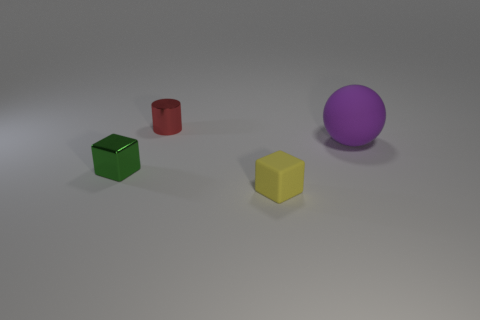Add 1 small red cylinders. How many objects exist? 5 Subtract all cylinders. How many objects are left? 3 Add 2 shiny objects. How many shiny objects are left? 4 Add 1 small green shiny things. How many small green shiny things exist? 2 Subtract 0 blue cylinders. How many objects are left? 4 Subtract all large rubber cylinders. Subtract all big purple rubber objects. How many objects are left? 3 